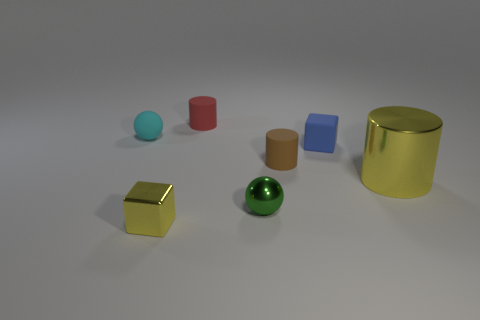Add 2 blocks. How many objects exist? 9 Subtract all cylinders. How many objects are left? 4 Subtract all cyan spheres. Subtract all small red matte cylinders. How many objects are left? 5 Add 6 small metallic spheres. How many small metallic spheres are left? 7 Add 6 big metallic cylinders. How many big metallic cylinders exist? 7 Subtract 0 purple blocks. How many objects are left? 7 